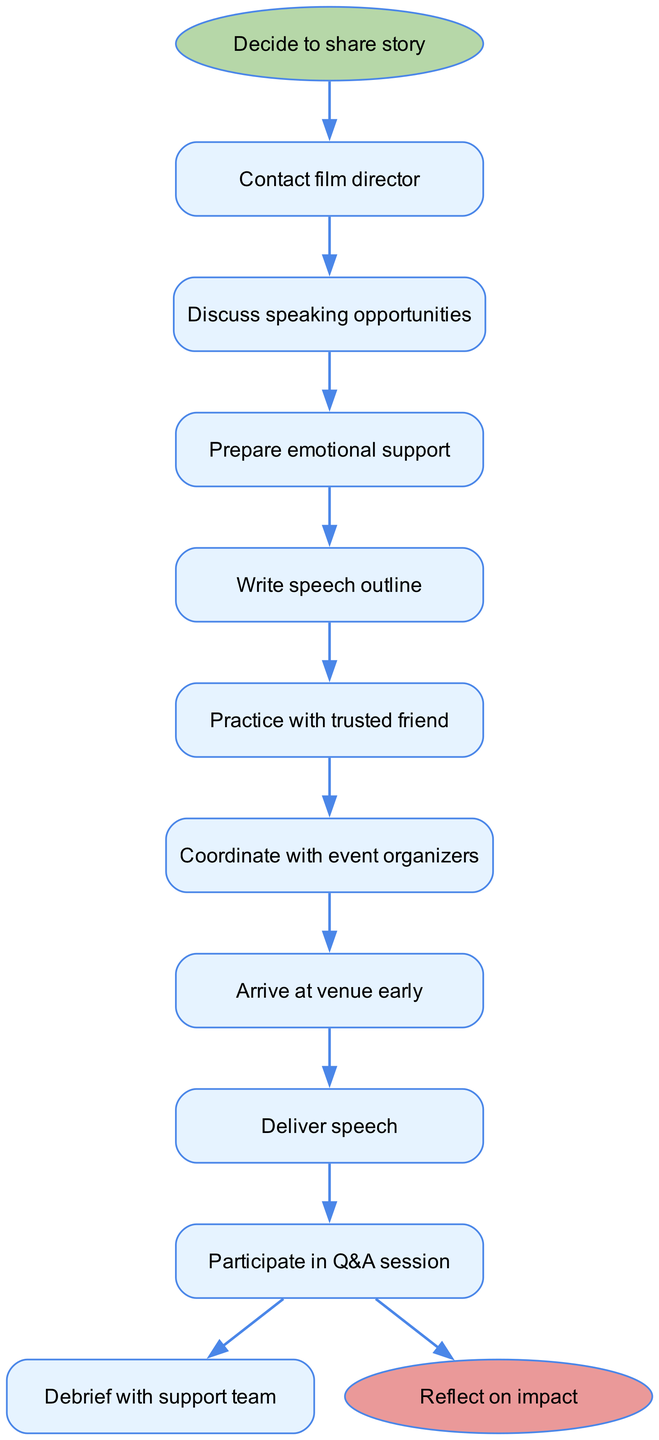What is the first step in the diagram? The first step is labeled 'Decide to share story', which is directly connected from the start node. This node indicates the initiation of the flow process.
Answer: Decide to share story How many steps are there in total? The diagram lists nine steps, starting from 'Contact film director' and ending with 'Participate in Q&A session' before reaching the end node. Each step represents a distinct action in the flow.
Answer: Nine What follows after 'Arrive at venue early'? According to the flow, the next step after 'Arrive at venue early' is 'Deliver speech'. This indicates the continuation of actions towards the goal of the engagement.
Answer: Deliver speech What is the last step before reflecting on impact? The last step before reaching the end node labeled 'Reflect on impact' is 'Participate in Q&A session'. This signifies the completion of the speaking engagement process.
Answer: Participate in Q&A session How are 'Discuss speaking opportunities' and 'Prepare emotional support' related? 'Discuss speaking opportunities' is directly connected to 'Prepare emotional support', indicating that after discussing, the next logical action is to prepare for emotional needs related to sharing the story.
Answer: Sequentially connected What is the end result of the process? The process culminates in the conclusion labeled 'Reflect on impact'. This summarizes the outcome of the entire engagement cycle, focusing on the survivor's experience.
Answer: Reflect on impact Which step directly follows 'Write speech outline'? The step that directly follows 'Write speech outline' is 'Practice with trusted friend', showing the progression from outlining to rehearsal in preparation for the speech.
Answer: Practice with trusted friend Is there an emotional support step in the process? Yes, 'Prepare emotional support' is a dedicated step that highlights the importance of mental and emotional readiness before proceeding with the speaking engagement.
Answer: Yes 